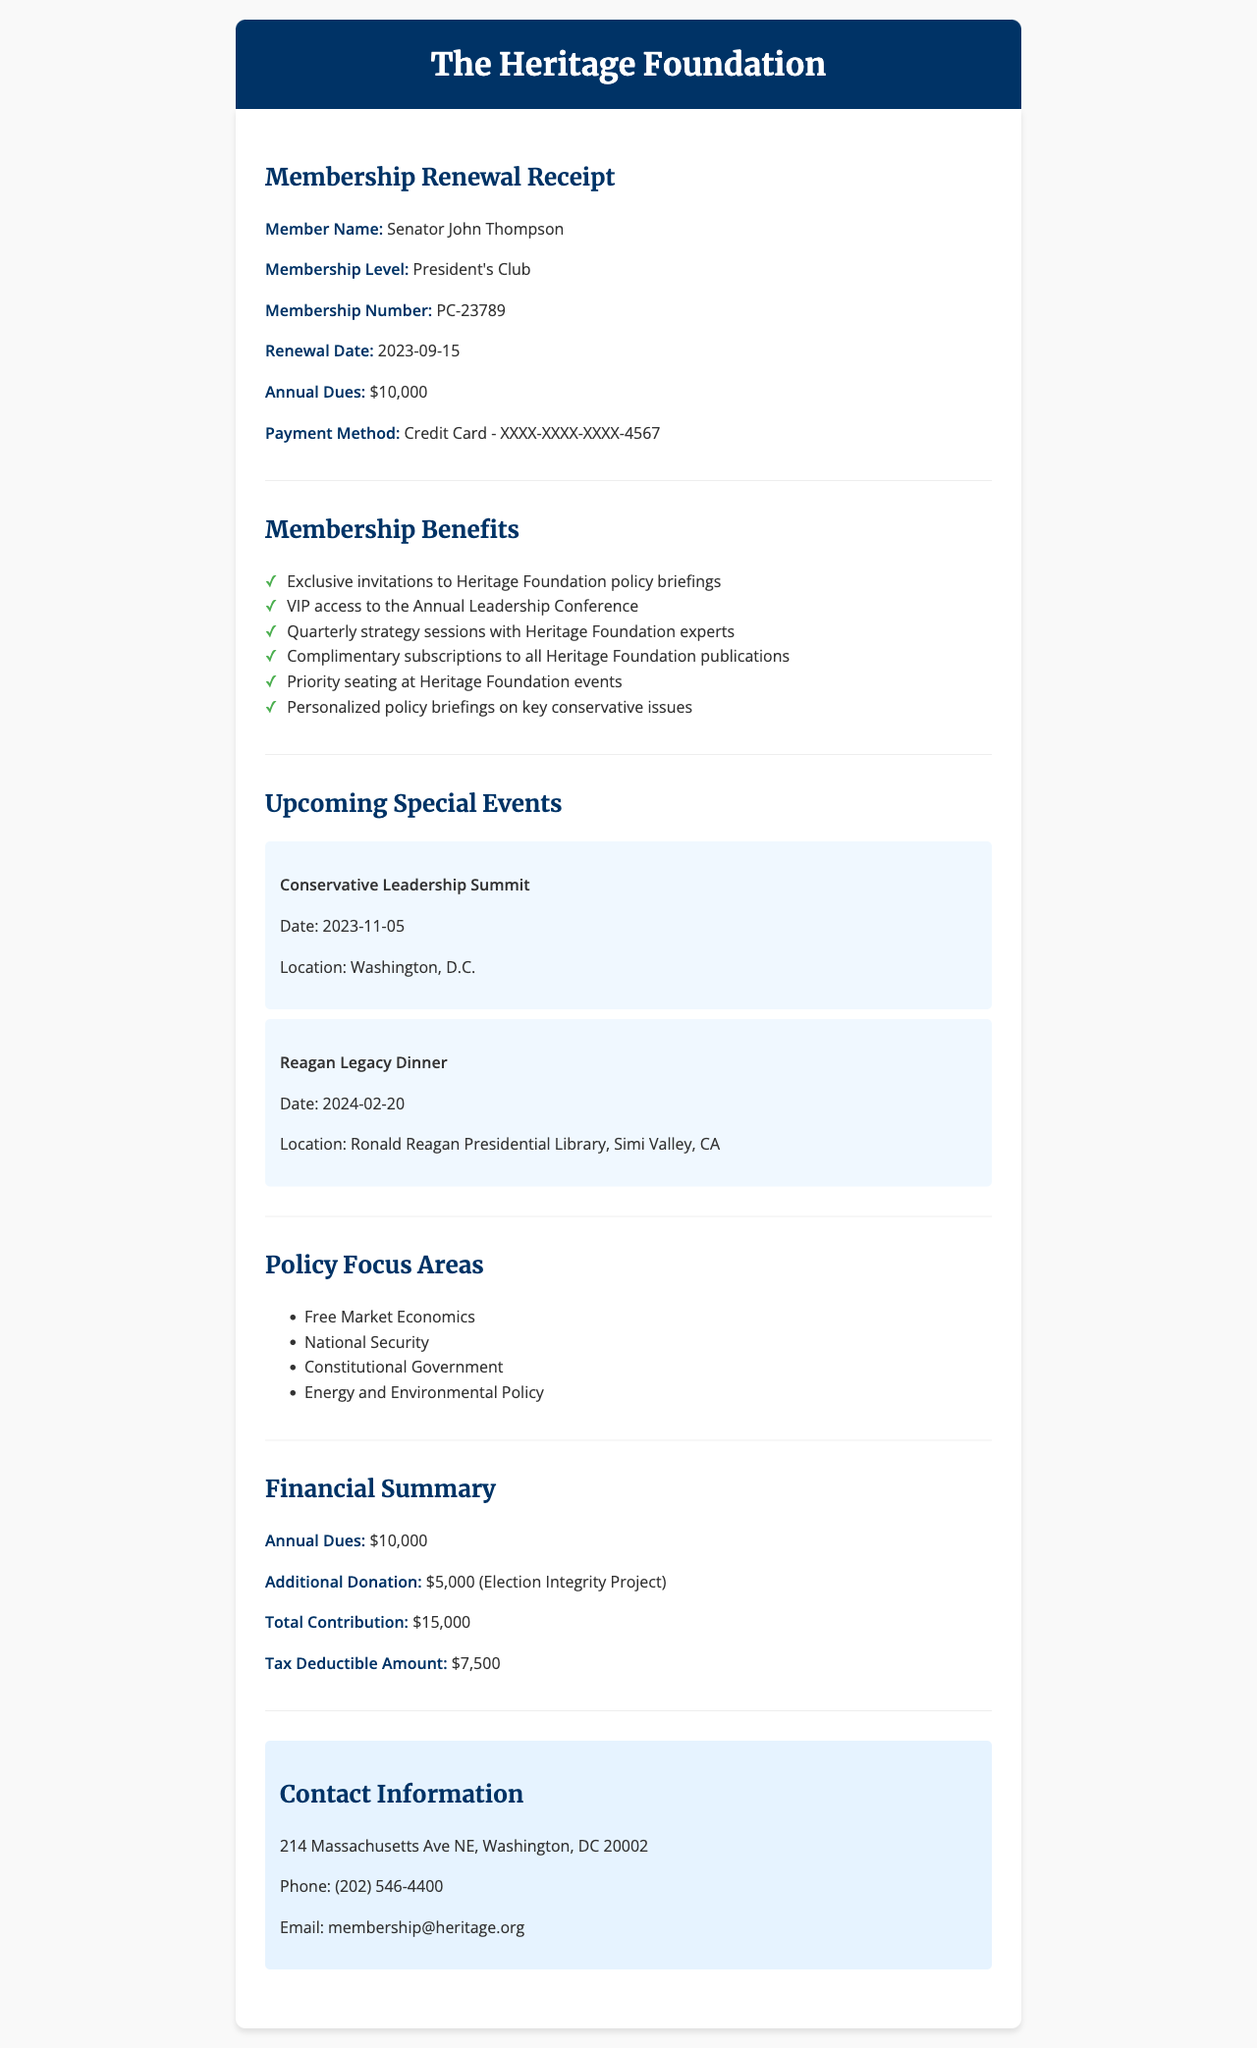What is the organization name? The organization name is clearly stated at the top of the document as part of the header.
Answer: The Heritage Foundation Who is the member? The member's name is listed in the membership renewal receipt.
Answer: Senator John Thompson What is the membership level? The membership level is specified within the content of the document.
Answer: President's Club What is the annual dues? The annual dues amount is highlighted in the financial summary section of the document.
Answer: $10,000 What is the tax deductible amount? The document specifies the amount that is tax deductible in the financial summary section.
Answer: $7,500 When is the Conservative Leadership Summit? The event's date is mentioned in the upcoming special events section.
Answer: 2023-11-05 What are two policy focus areas? The policy focus areas section lists multiple areas of focus from which two can be selected based on the document.
Answer: Free Market Economics, National Security What is the additional donation amount? The additional donation amount is specified in the financial summary section of the receipt.
Answer: $5,000 Where is the contact address located? The contact information section includes the full address for the organization.
Answer: 214 Massachusetts Ave NE, Washington, DC 20002 